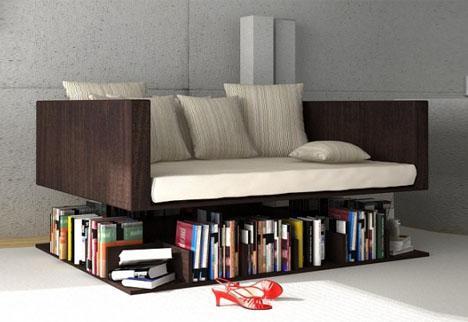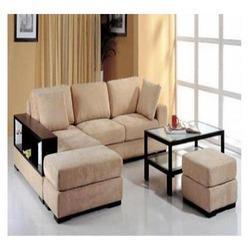The first image is the image on the left, the second image is the image on the right. For the images displayed, is the sentence "There is a stack of three books on the front-most corner of the shelf under the couch in the image on the left." factually correct? Answer yes or no. Yes. The first image is the image on the left, the second image is the image on the right. For the images displayed, is the sentence "there is a book shelf with a sofa and a rug on the floor" factually correct? Answer yes or no. No. 